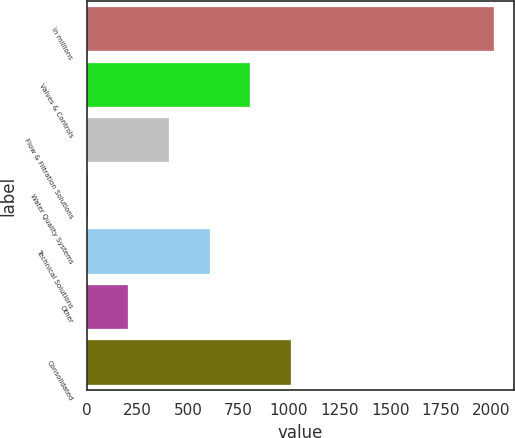<chart> <loc_0><loc_0><loc_500><loc_500><bar_chart><fcel>In millions<fcel>Valves & Controls<fcel>Flow & Filtration Solutions<fcel>Water Quality Systems<fcel>Technical Solutions<fcel>Other<fcel>Consolidated<nl><fcel>2013<fcel>808.2<fcel>406.6<fcel>5<fcel>607.4<fcel>205.8<fcel>1009<nl></chart> 